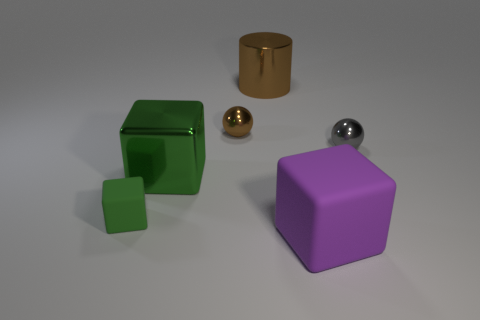Subtract all purple matte blocks. How many blocks are left? 2 Subtract all purple cylinders. How many green cubes are left? 2 Add 2 brown cylinders. How many objects exist? 8 Subtract all gray balls. How many balls are left? 1 Subtract all cylinders. How many objects are left? 5 Subtract all purple objects. Subtract all large purple matte blocks. How many objects are left? 4 Add 6 tiny brown shiny objects. How many tiny brown shiny objects are left? 7 Add 5 brown metallic cylinders. How many brown metallic cylinders exist? 6 Subtract 1 green cubes. How many objects are left? 5 Subtract all red cylinders. Subtract all blue blocks. How many cylinders are left? 1 